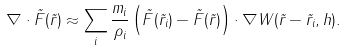<formula> <loc_0><loc_0><loc_500><loc_500>\nabla \cdot \vec { F } ( \vec { r } ) \approx \sum _ { i } \frac { m _ { i } } { \rho _ { i } } \left ( \vec { F } ( \vec { r } _ { i } ) - \vec { F } ( \vec { r } ) \right ) \cdot \nabla W ( \vec { r } - \vec { r } _ { i } , h ) .</formula> 